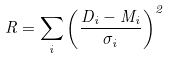<formula> <loc_0><loc_0><loc_500><loc_500>R = \sum _ { i } \left ( \frac { D _ { i } - M _ { i } } { \sigma _ { i } } \right ) ^ { 2 }</formula> 